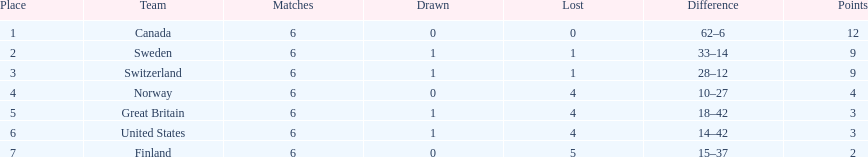What was the number of points won by great britain? 3. 